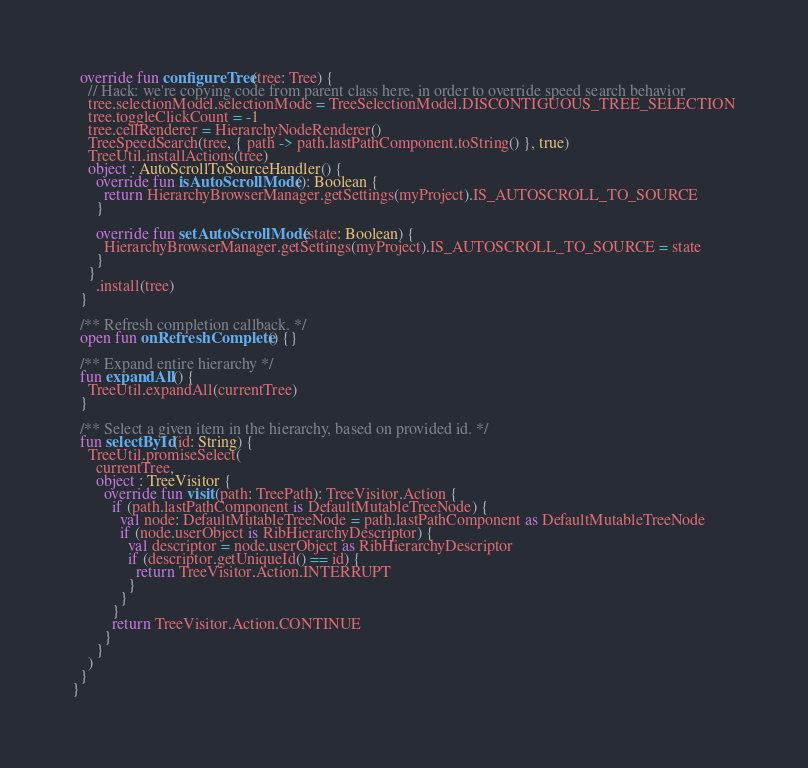Convert code to text. <code><loc_0><loc_0><loc_500><loc_500><_Kotlin_>  override fun configureTree(tree: Tree) {
    // Hack: we're copying code from parent class here, in order to override speed search behavior
    tree.selectionModel.selectionMode = TreeSelectionModel.DISCONTIGUOUS_TREE_SELECTION
    tree.toggleClickCount = -1
    tree.cellRenderer = HierarchyNodeRenderer()
    TreeSpeedSearch(tree, { path -> path.lastPathComponent.toString() }, true)
    TreeUtil.installActions(tree)
    object : AutoScrollToSourceHandler() {
      override fun isAutoScrollMode(): Boolean {
        return HierarchyBrowserManager.getSettings(myProject).IS_AUTOSCROLL_TO_SOURCE
      }

      override fun setAutoScrollMode(state: Boolean) {
        HierarchyBrowserManager.getSettings(myProject).IS_AUTOSCROLL_TO_SOURCE = state
      }
    }
      .install(tree)
  }

  /** Refresh completion callback. */
  open fun onRefreshComplete() {}

  /** Expand entire hierarchy */
  fun expandAll() {
    TreeUtil.expandAll(currentTree)
  }

  /** Select a given item in the hierarchy, based on provided id. */
  fun selectById(id: String) {
    TreeUtil.promiseSelect(
      currentTree,
      object : TreeVisitor {
        override fun visit(path: TreePath): TreeVisitor.Action {
          if (path.lastPathComponent is DefaultMutableTreeNode) {
            val node: DefaultMutableTreeNode = path.lastPathComponent as DefaultMutableTreeNode
            if (node.userObject is RibHierarchyDescriptor) {
              val descriptor = node.userObject as RibHierarchyDescriptor
              if (descriptor.getUniqueId() == id) {
                return TreeVisitor.Action.INTERRUPT
              }
            }
          }
          return TreeVisitor.Action.CONTINUE
        }
      }
    )
  }
}
</code> 